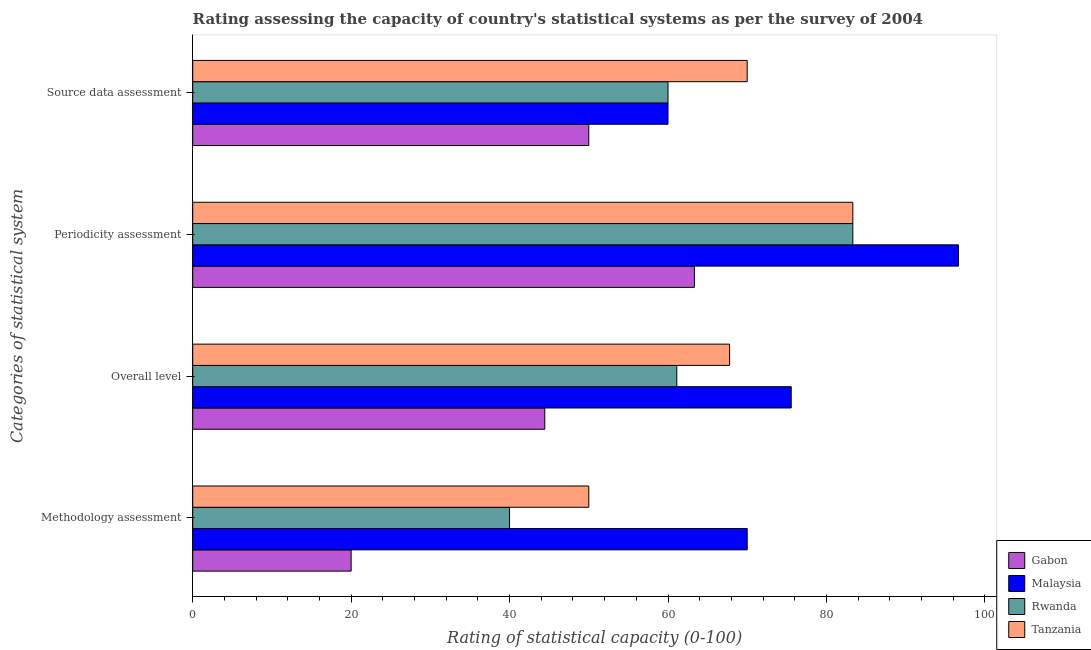How many bars are there on the 3rd tick from the bottom?
Offer a terse response. 4. What is the label of the 4th group of bars from the top?
Your answer should be compact. Methodology assessment. Across all countries, what is the maximum periodicity assessment rating?
Keep it short and to the point. 96.67. Across all countries, what is the minimum source data assessment rating?
Offer a very short reply. 50. In which country was the overall level rating maximum?
Offer a very short reply. Malaysia. In which country was the source data assessment rating minimum?
Offer a terse response. Gabon. What is the total source data assessment rating in the graph?
Your answer should be compact. 240. What is the difference between the methodology assessment rating in Malaysia and that in Tanzania?
Your answer should be compact. 20. What is the difference between the source data assessment rating in Rwanda and the overall level rating in Gabon?
Your response must be concise. 15.56. What is the difference between the source data assessment rating and overall level rating in Rwanda?
Your response must be concise. -1.11. In how many countries, is the methodology assessment rating greater than 92 ?
Give a very brief answer. 0. What is the ratio of the source data assessment rating in Gabon to that in Malaysia?
Your answer should be very brief. 0.83. Is the overall level rating in Gabon less than that in Malaysia?
Your answer should be compact. Yes. Is the difference between the periodicity assessment rating in Malaysia and Gabon greater than the difference between the source data assessment rating in Malaysia and Gabon?
Offer a very short reply. Yes. What is the difference between the highest and the second highest methodology assessment rating?
Keep it short and to the point. 20. What is the difference between the highest and the lowest methodology assessment rating?
Your answer should be compact. 50. In how many countries, is the periodicity assessment rating greater than the average periodicity assessment rating taken over all countries?
Your answer should be compact. 3. Is it the case that in every country, the sum of the periodicity assessment rating and overall level rating is greater than the sum of source data assessment rating and methodology assessment rating?
Offer a very short reply. No. What does the 4th bar from the top in Overall level represents?
Ensure brevity in your answer.  Gabon. What does the 4th bar from the bottom in Periodicity assessment represents?
Give a very brief answer. Tanzania. Is it the case that in every country, the sum of the methodology assessment rating and overall level rating is greater than the periodicity assessment rating?
Your answer should be compact. Yes. Are all the bars in the graph horizontal?
Make the answer very short. Yes. Does the graph contain any zero values?
Your answer should be very brief. No. Where does the legend appear in the graph?
Your answer should be compact. Bottom right. How are the legend labels stacked?
Your answer should be compact. Vertical. What is the title of the graph?
Your answer should be very brief. Rating assessing the capacity of country's statistical systems as per the survey of 2004 . Does "Latin America(developing only)" appear as one of the legend labels in the graph?
Your answer should be compact. No. What is the label or title of the X-axis?
Keep it short and to the point. Rating of statistical capacity (0-100). What is the label or title of the Y-axis?
Give a very brief answer. Categories of statistical system. What is the Rating of statistical capacity (0-100) in Gabon in Methodology assessment?
Keep it short and to the point. 20. What is the Rating of statistical capacity (0-100) of Malaysia in Methodology assessment?
Provide a short and direct response. 70. What is the Rating of statistical capacity (0-100) in Gabon in Overall level?
Keep it short and to the point. 44.44. What is the Rating of statistical capacity (0-100) in Malaysia in Overall level?
Keep it short and to the point. 75.56. What is the Rating of statistical capacity (0-100) in Rwanda in Overall level?
Ensure brevity in your answer.  61.11. What is the Rating of statistical capacity (0-100) of Tanzania in Overall level?
Give a very brief answer. 67.78. What is the Rating of statistical capacity (0-100) in Gabon in Periodicity assessment?
Provide a succinct answer. 63.33. What is the Rating of statistical capacity (0-100) of Malaysia in Periodicity assessment?
Provide a succinct answer. 96.67. What is the Rating of statistical capacity (0-100) of Rwanda in Periodicity assessment?
Offer a terse response. 83.33. What is the Rating of statistical capacity (0-100) in Tanzania in Periodicity assessment?
Keep it short and to the point. 83.33. What is the Rating of statistical capacity (0-100) in Gabon in Source data assessment?
Your response must be concise. 50. What is the Rating of statistical capacity (0-100) in Malaysia in Source data assessment?
Your answer should be compact. 60. What is the Rating of statistical capacity (0-100) in Rwanda in Source data assessment?
Keep it short and to the point. 60. What is the Rating of statistical capacity (0-100) in Tanzania in Source data assessment?
Offer a terse response. 70. Across all Categories of statistical system, what is the maximum Rating of statistical capacity (0-100) in Gabon?
Provide a succinct answer. 63.33. Across all Categories of statistical system, what is the maximum Rating of statistical capacity (0-100) in Malaysia?
Offer a very short reply. 96.67. Across all Categories of statistical system, what is the maximum Rating of statistical capacity (0-100) in Rwanda?
Make the answer very short. 83.33. Across all Categories of statistical system, what is the maximum Rating of statistical capacity (0-100) of Tanzania?
Offer a terse response. 83.33. Across all Categories of statistical system, what is the minimum Rating of statistical capacity (0-100) of Gabon?
Provide a succinct answer. 20. Across all Categories of statistical system, what is the minimum Rating of statistical capacity (0-100) in Tanzania?
Ensure brevity in your answer.  50. What is the total Rating of statistical capacity (0-100) of Gabon in the graph?
Ensure brevity in your answer.  177.78. What is the total Rating of statistical capacity (0-100) of Malaysia in the graph?
Offer a terse response. 302.22. What is the total Rating of statistical capacity (0-100) of Rwanda in the graph?
Your response must be concise. 244.44. What is the total Rating of statistical capacity (0-100) of Tanzania in the graph?
Make the answer very short. 271.11. What is the difference between the Rating of statistical capacity (0-100) in Gabon in Methodology assessment and that in Overall level?
Provide a succinct answer. -24.44. What is the difference between the Rating of statistical capacity (0-100) in Malaysia in Methodology assessment and that in Overall level?
Give a very brief answer. -5.56. What is the difference between the Rating of statistical capacity (0-100) of Rwanda in Methodology assessment and that in Overall level?
Ensure brevity in your answer.  -21.11. What is the difference between the Rating of statistical capacity (0-100) in Tanzania in Methodology assessment and that in Overall level?
Keep it short and to the point. -17.78. What is the difference between the Rating of statistical capacity (0-100) in Gabon in Methodology assessment and that in Periodicity assessment?
Ensure brevity in your answer.  -43.33. What is the difference between the Rating of statistical capacity (0-100) of Malaysia in Methodology assessment and that in Periodicity assessment?
Your answer should be compact. -26.67. What is the difference between the Rating of statistical capacity (0-100) of Rwanda in Methodology assessment and that in Periodicity assessment?
Provide a succinct answer. -43.33. What is the difference between the Rating of statistical capacity (0-100) in Tanzania in Methodology assessment and that in Periodicity assessment?
Make the answer very short. -33.33. What is the difference between the Rating of statistical capacity (0-100) of Rwanda in Methodology assessment and that in Source data assessment?
Your answer should be compact. -20. What is the difference between the Rating of statistical capacity (0-100) of Tanzania in Methodology assessment and that in Source data assessment?
Offer a terse response. -20. What is the difference between the Rating of statistical capacity (0-100) in Gabon in Overall level and that in Periodicity assessment?
Your answer should be compact. -18.89. What is the difference between the Rating of statistical capacity (0-100) in Malaysia in Overall level and that in Periodicity assessment?
Give a very brief answer. -21.11. What is the difference between the Rating of statistical capacity (0-100) of Rwanda in Overall level and that in Periodicity assessment?
Provide a succinct answer. -22.22. What is the difference between the Rating of statistical capacity (0-100) of Tanzania in Overall level and that in Periodicity assessment?
Make the answer very short. -15.56. What is the difference between the Rating of statistical capacity (0-100) of Gabon in Overall level and that in Source data assessment?
Your answer should be compact. -5.56. What is the difference between the Rating of statistical capacity (0-100) of Malaysia in Overall level and that in Source data assessment?
Offer a very short reply. 15.56. What is the difference between the Rating of statistical capacity (0-100) of Tanzania in Overall level and that in Source data assessment?
Your response must be concise. -2.22. What is the difference between the Rating of statistical capacity (0-100) of Gabon in Periodicity assessment and that in Source data assessment?
Ensure brevity in your answer.  13.33. What is the difference between the Rating of statistical capacity (0-100) of Malaysia in Periodicity assessment and that in Source data assessment?
Give a very brief answer. 36.67. What is the difference between the Rating of statistical capacity (0-100) in Rwanda in Periodicity assessment and that in Source data assessment?
Ensure brevity in your answer.  23.33. What is the difference between the Rating of statistical capacity (0-100) of Tanzania in Periodicity assessment and that in Source data assessment?
Keep it short and to the point. 13.33. What is the difference between the Rating of statistical capacity (0-100) in Gabon in Methodology assessment and the Rating of statistical capacity (0-100) in Malaysia in Overall level?
Provide a short and direct response. -55.56. What is the difference between the Rating of statistical capacity (0-100) of Gabon in Methodology assessment and the Rating of statistical capacity (0-100) of Rwanda in Overall level?
Offer a very short reply. -41.11. What is the difference between the Rating of statistical capacity (0-100) of Gabon in Methodology assessment and the Rating of statistical capacity (0-100) of Tanzania in Overall level?
Make the answer very short. -47.78. What is the difference between the Rating of statistical capacity (0-100) of Malaysia in Methodology assessment and the Rating of statistical capacity (0-100) of Rwanda in Overall level?
Your answer should be compact. 8.89. What is the difference between the Rating of statistical capacity (0-100) of Malaysia in Methodology assessment and the Rating of statistical capacity (0-100) of Tanzania in Overall level?
Make the answer very short. 2.22. What is the difference between the Rating of statistical capacity (0-100) in Rwanda in Methodology assessment and the Rating of statistical capacity (0-100) in Tanzania in Overall level?
Provide a short and direct response. -27.78. What is the difference between the Rating of statistical capacity (0-100) of Gabon in Methodology assessment and the Rating of statistical capacity (0-100) of Malaysia in Periodicity assessment?
Make the answer very short. -76.67. What is the difference between the Rating of statistical capacity (0-100) in Gabon in Methodology assessment and the Rating of statistical capacity (0-100) in Rwanda in Periodicity assessment?
Make the answer very short. -63.33. What is the difference between the Rating of statistical capacity (0-100) of Gabon in Methodology assessment and the Rating of statistical capacity (0-100) of Tanzania in Periodicity assessment?
Give a very brief answer. -63.33. What is the difference between the Rating of statistical capacity (0-100) in Malaysia in Methodology assessment and the Rating of statistical capacity (0-100) in Rwanda in Periodicity assessment?
Keep it short and to the point. -13.33. What is the difference between the Rating of statistical capacity (0-100) of Malaysia in Methodology assessment and the Rating of statistical capacity (0-100) of Tanzania in Periodicity assessment?
Make the answer very short. -13.33. What is the difference between the Rating of statistical capacity (0-100) in Rwanda in Methodology assessment and the Rating of statistical capacity (0-100) in Tanzania in Periodicity assessment?
Your response must be concise. -43.33. What is the difference between the Rating of statistical capacity (0-100) in Gabon in Methodology assessment and the Rating of statistical capacity (0-100) in Malaysia in Source data assessment?
Your answer should be compact. -40. What is the difference between the Rating of statistical capacity (0-100) of Gabon in Methodology assessment and the Rating of statistical capacity (0-100) of Tanzania in Source data assessment?
Give a very brief answer. -50. What is the difference between the Rating of statistical capacity (0-100) in Malaysia in Methodology assessment and the Rating of statistical capacity (0-100) in Rwanda in Source data assessment?
Your answer should be compact. 10. What is the difference between the Rating of statistical capacity (0-100) of Rwanda in Methodology assessment and the Rating of statistical capacity (0-100) of Tanzania in Source data assessment?
Offer a terse response. -30. What is the difference between the Rating of statistical capacity (0-100) of Gabon in Overall level and the Rating of statistical capacity (0-100) of Malaysia in Periodicity assessment?
Your answer should be very brief. -52.22. What is the difference between the Rating of statistical capacity (0-100) of Gabon in Overall level and the Rating of statistical capacity (0-100) of Rwanda in Periodicity assessment?
Ensure brevity in your answer.  -38.89. What is the difference between the Rating of statistical capacity (0-100) of Gabon in Overall level and the Rating of statistical capacity (0-100) of Tanzania in Periodicity assessment?
Make the answer very short. -38.89. What is the difference between the Rating of statistical capacity (0-100) in Malaysia in Overall level and the Rating of statistical capacity (0-100) in Rwanda in Periodicity assessment?
Make the answer very short. -7.78. What is the difference between the Rating of statistical capacity (0-100) of Malaysia in Overall level and the Rating of statistical capacity (0-100) of Tanzania in Periodicity assessment?
Ensure brevity in your answer.  -7.78. What is the difference between the Rating of statistical capacity (0-100) of Rwanda in Overall level and the Rating of statistical capacity (0-100) of Tanzania in Periodicity assessment?
Ensure brevity in your answer.  -22.22. What is the difference between the Rating of statistical capacity (0-100) of Gabon in Overall level and the Rating of statistical capacity (0-100) of Malaysia in Source data assessment?
Keep it short and to the point. -15.56. What is the difference between the Rating of statistical capacity (0-100) in Gabon in Overall level and the Rating of statistical capacity (0-100) in Rwanda in Source data assessment?
Provide a succinct answer. -15.56. What is the difference between the Rating of statistical capacity (0-100) of Gabon in Overall level and the Rating of statistical capacity (0-100) of Tanzania in Source data assessment?
Provide a succinct answer. -25.56. What is the difference between the Rating of statistical capacity (0-100) of Malaysia in Overall level and the Rating of statistical capacity (0-100) of Rwanda in Source data assessment?
Offer a terse response. 15.56. What is the difference between the Rating of statistical capacity (0-100) of Malaysia in Overall level and the Rating of statistical capacity (0-100) of Tanzania in Source data assessment?
Ensure brevity in your answer.  5.56. What is the difference between the Rating of statistical capacity (0-100) of Rwanda in Overall level and the Rating of statistical capacity (0-100) of Tanzania in Source data assessment?
Give a very brief answer. -8.89. What is the difference between the Rating of statistical capacity (0-100) in Gabon in Periodicity assessment and the Rating of statistical capacity (0-100) in Rwanda in Source data assessment?
Provide a succinct answer. 3.33. What is the difference between the Rating of statistical capacity (0-100) of Gabon in Periodicity assessment and the Rating of statistical capacity (0-100) of Tanzania in Source data assessment?
Your answer should be compact. -6.67. What is the difference between the Rating of statistical capacity (0-100) of Malaysia in Periodicity assessment and the Rating of statistical capacity (0-100) of Rwanda in Source data assessment?
Ensure brevity in your answer.  36.67. What is the difference between the Rating of statistical capacity (0-100) of Malaysia in Periodicity assessment and the Rating of statistical capacity (0-100) of Tanzania in Source data assessment?
Give a very brief answer. 26.67. What is the difference between the Rating of statistical capacity (0-100) in Rwanda in Periodicity assessment and the Rating of statistical capacity (0-100) in Tanzania in Source data assessment?
Make the answer very short. 13.33. What is the average Rating of statistical capacity (0-100) in Gabon per Categories of statistical system?
Your answer should be compact. 44.44. What is the average Rating of statistical capacity (0-100) in Malaysia per Categories of statistical system?
Your answer should be very brief. 75.56. What is the average Rating of statistical capacity (0-100) of Rwanda per Categories of statistical system?
Your answer should be very brief. 61.11. What is the average Rating of statistical capacity (0-100) of Tanzania per Categories of statistical system?
Offer a very short reply. 67.78. What is the difference between the Rating of statistical capacity (0-100) of Malaysia and Rating of statistical capacity (0-100) of Tanzania in Methodology assessment?
Provide a short and direct response. 20. What is the difference between the Rating of statistical capacity (0-100) of Gabon and Rating of statistical capacity (0-100) of Malaysia in Overall level?
Provide a short and direct response. -31.11. What is the difference between the Rating of statistical capacity (0-100) of Gabon and Rating of statistical capacity (0-100) of Rwanda in Overall level?
Ensure brevity in your answer.  -16.67. What is the difference between the Rating of statistical capacity (0-100) of Gabon and Rating of statistical capacity (0-100) of Tanzania in Overall level?
Your response must be concise. -23.33. What is the difference between the Rating of statistical capacity (0-100) of Malaysia and Rating of statistical capacity (0-100) of Rwanda in Overall level?
Your response must be concise. 14.44. What is the difference between the Rating of statistical capacity (0-100) of Malaysia and Rating of statistical capacity (0-100) of Tanzania in Overall level?
Provide a short and direct response. 7.78. What is the difference between the Rating of statistical capacity (0-100) in Rwanda and Rating of statistical capacity (0-100) in Tanzania in Overall level?
Keep it short and to the point. -6.67. What is the difference between the Rating of statistical capacity (0-100) in Gabon and Rating of statistical capacity (0-100) in Malaysia in Periodicity assessment?
Offer a very short reply. -33.33. What is the difference between the Rating of statistical capacity (0-100) of Gabon and Rating of statistical capacity (0-100) of Rwanda in Periodicity assessment?
Give a very brief answer. -20. What is the difference between the Rating of statistical capacity (0-100) of Malaysia and Rating of statistical capacity (0-100) of Rwanda in Periodicity assessment?
Provide a short and direct response. 13.33. What is the difference between the Rating of statistical capacity (0-100) in Malaysia and Rating of statistical capacity (0-100) in Tanzania in Periodicity assessment?
Your response must be concise. 13.33. What is the difference between the Rating of statistical capacity (0-100) in Gabon and Rating of statistical capacity (0-100) in Rwanda in Source data assessment?
Provide a succinct answer. -10. What is the difference between the Rating of statistical capacity (0-100) in Gabon and Rating of statistical capacity (0-100) in Tanzania in Source data assessment?
Your answer should be compact. -20. What is the difference between the Rating of statistical capacity (0-100) of Malaysia and Rating of statistical capacity (0-100) of Tanzania in Source data assessment?
Your answer should be compact. -10. What is the ratio of the Rating of statistical capacity (0-100) of Gabon in Methodology assessment to that in Overall level?
Provide a short and direct response. 0.45. What is the ratio of the Rating of statistical capacity (0-100) of Malaysia in Methodology assessment to that in Overall level?
Keep it short and to the point. 0.93. What is the ratio of the Rating of statistical capacity (0-100) of Rwanda in Methodology assessment to that in Overall level?
Offer a terse response. 0.65. What is the ratio of the Rating of statistical capacity (0-100) of Tanzania in Methodology assessment to that in Overall level?
Give a very brief answer. 0.74. What is the ratio of the Rating of statistical capacity (0-100) of Gabon in Methodology assessment to that in Periodicity assessment?
Your answer should be compact. 0.32. What is the ratio of the Rating of statistical capacity (0-100) in Malaysia in Methodology assessment to that in Periodicity assessment?
Give a very brief answer. 0.72. What is the ratio of the Rating of statistical capacity (0-100) in Rwanda in Methodology assessment to that in Periodicity assessment?
Your answer should be very brief. 0.48. What is the ratio of the Rating of statistical capacity (0-100) of Tanzania in Methodology assessment to that in Periodicity assessment?
Make the answer very short. 0.6. What is the ratio of the Rating of statistical capacity (0-100) of Tanzania in Methodology assessment to that in Source data assessment?
Provide a succinct answer. 0.71. What is the ratio of the Rating of statistical capacity (0-100) in Gabon in Overall level to that in Periodicity assessment?
Keep it short and to the point. 0.7. What is the ratio of the Rating of statistical capacity (0-100) in Malaysia in Overall level to that in Periodicity assessment?
Offer a very short reply. 0.78. What is the ratio of the Rating of statistical capacity (0-100) in Rwanda in Overall level to that in Periodicity assessment?
Provide a succinct answer. 0.73. What is the ratio of the Rating of statistical capacity (0-100) of Tanzania in Overall level to that in Periodicity assessment?
Offer a terse response. 0.81. What is the ratio of the Rating of statistical capacity (0-100) of Gabon in Overall level to that in Source data assessment?
Ensure brevity in your answer.  0.89. What is the ratio of the Rating of statistical capacity (0-100) in Malaysia in Overall level to that in Source data assessment?
Offer a terse response. 1.26. What is the ratio of the Rating of statistical capacity (0-100) of Rwanda in Overall level to that in Source data assessment?
Give a very brief answer. 1.02. What is the ratio of the Rating of statistical capacity (0-100) of Tanzania in Overall level to that in Source data assessment?
Provide a succinct answer. 0.97. What is the ratio of the Rating of statistical capacity (0-100) in Gabon in Periodicity assessment to that in Source data assessment?
Give a very brief answer. 1.27. What is the ratio of the Rating of statistical capacity (0-100) of Malaysia in Periodicity assessment to that in Source data assessment?
Provide a short and direct response. 1.61. What is the ratio of the Rating of statistical capacity (0-100) of Rwanda in Periodicity assessment to that in Source data assessment?
Your answer should be compact. 1.39. What is the ratio of the Rating of statistical capacity (0-100) in Tanzania in Periodicity assessment to that in Source data assessment?
Offer a very short reply. 1.19. What is the difference between the highest and the second highest Rating of statistical capacity (0-100) in Gabon?
Your answer should be very brief. 13.33. What is the difference between the highest and the second highest Rating of statistical capacity (0-100) in Malaysia?
Give a very brief answer. 21.11. What is the difference between the highest and the second highest Rating of statistical capacity (0-100) in Rwanda?
Ensure brevity in your answer.  22.22. What is the difference between the highest and the second highest Rating of statistical capacity (0-100) in Tanzania?
Your response must be concise. 13.33. What is the difference between the highest and the lowest Rating of statistical capacity (0-100) in Gabon?
Ensure brevity in your answer.  43.33. What is the difference between the highest and the lowest Rating of statistical capacity (0-100) of Malaysia?
Keep it short and to the point. 36.67. What is the difference between the highest and the lowest Rating of statistical capacity (0-100) of Rwanda?
Your answer should be compact. 43.33. What is the difference between the highest and the lowest Rating of statistical capacity (0-100) of Tanzania?
Your answer should be compact. 33.33. 